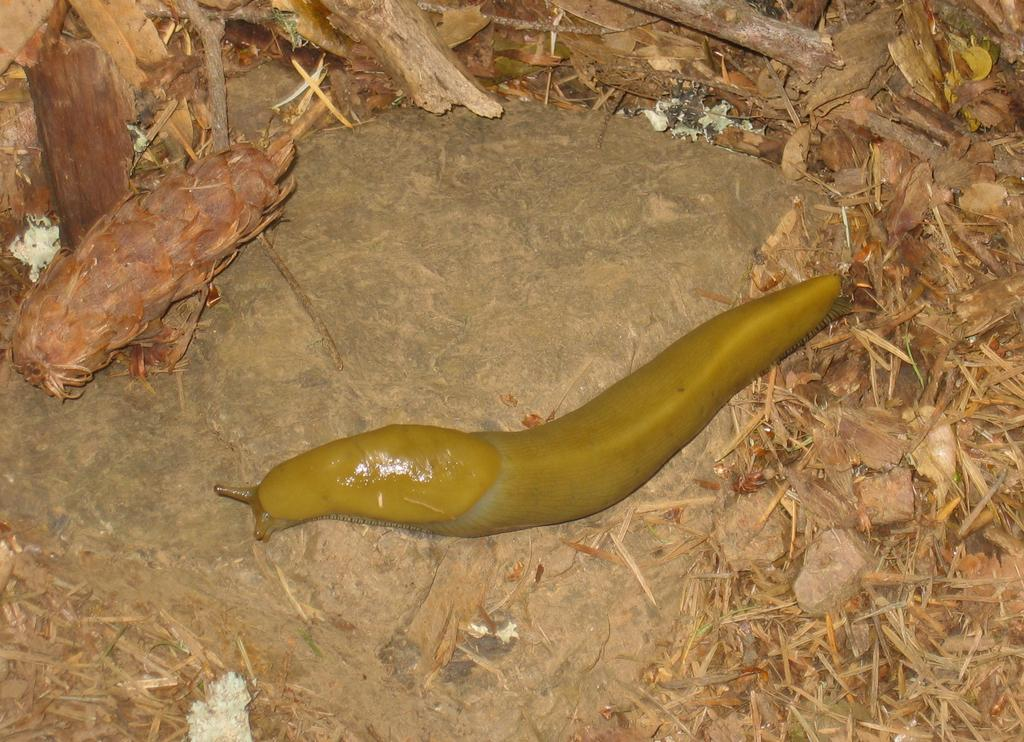What type of creature is on the floor in the image? There is a slug on the floor in the image. What other objects can be seen on the floor in the image? There are rocks and dry grass on the floor in the image. What does the son of the slug do at night in the image? There is no son of the slug present in the image, and the image does not depict any activities at night. Additionally, slugs do not have sons, as they are invertebrates and reproduce through eggs. There is no indication of any activity involving a slug's offspring or any activity at night in the image. --- Facts: 1. There is a person holding a book in the image. 2. The person is sitting on a chair. 3. There is a table next to the chair. 4. The book has a blue cover. Absurd Topics: elephant, ocean, dance Conversation: What is the person in the image holding? The person in the image is holding a book. What is the person's position in the image? The person is sitting on a chair. What is located next to the chair in the image? There is a table next to the chair. What is the color of the book's cover? The book has a blue cover. Reasoning: Let's think step by step in order to produce the conversation. We start by identifying the main subject in the image, which is the person holding a book. Then, we expand the conversation to include the person's position and the objects located nearby, such as the chair and table. Finally, we mention a specific detail about the book, which is the color of its cover. Absurd Question/Answer: Can you see an elephant swimming in the ocean in the image? No, there is no elephant or ocean present in the image. The image features a person sitting on a chair, holding a book with a blue cover, and a table nearby. 